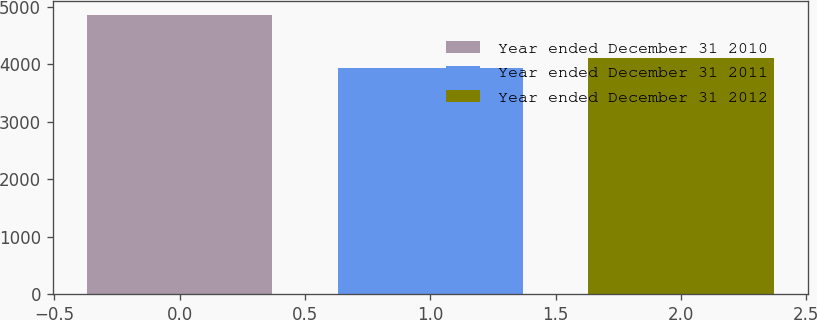<chart> <loc_0><loc_0><loc_500><loc_500><bar_chart><fcel>Year ended December 31 2010<fcel>Year ended December 31 2011<fcel>Year ended December 31 2012<nl><fcel>4860<fcel>3939<fcel>4106<nl></chart> 